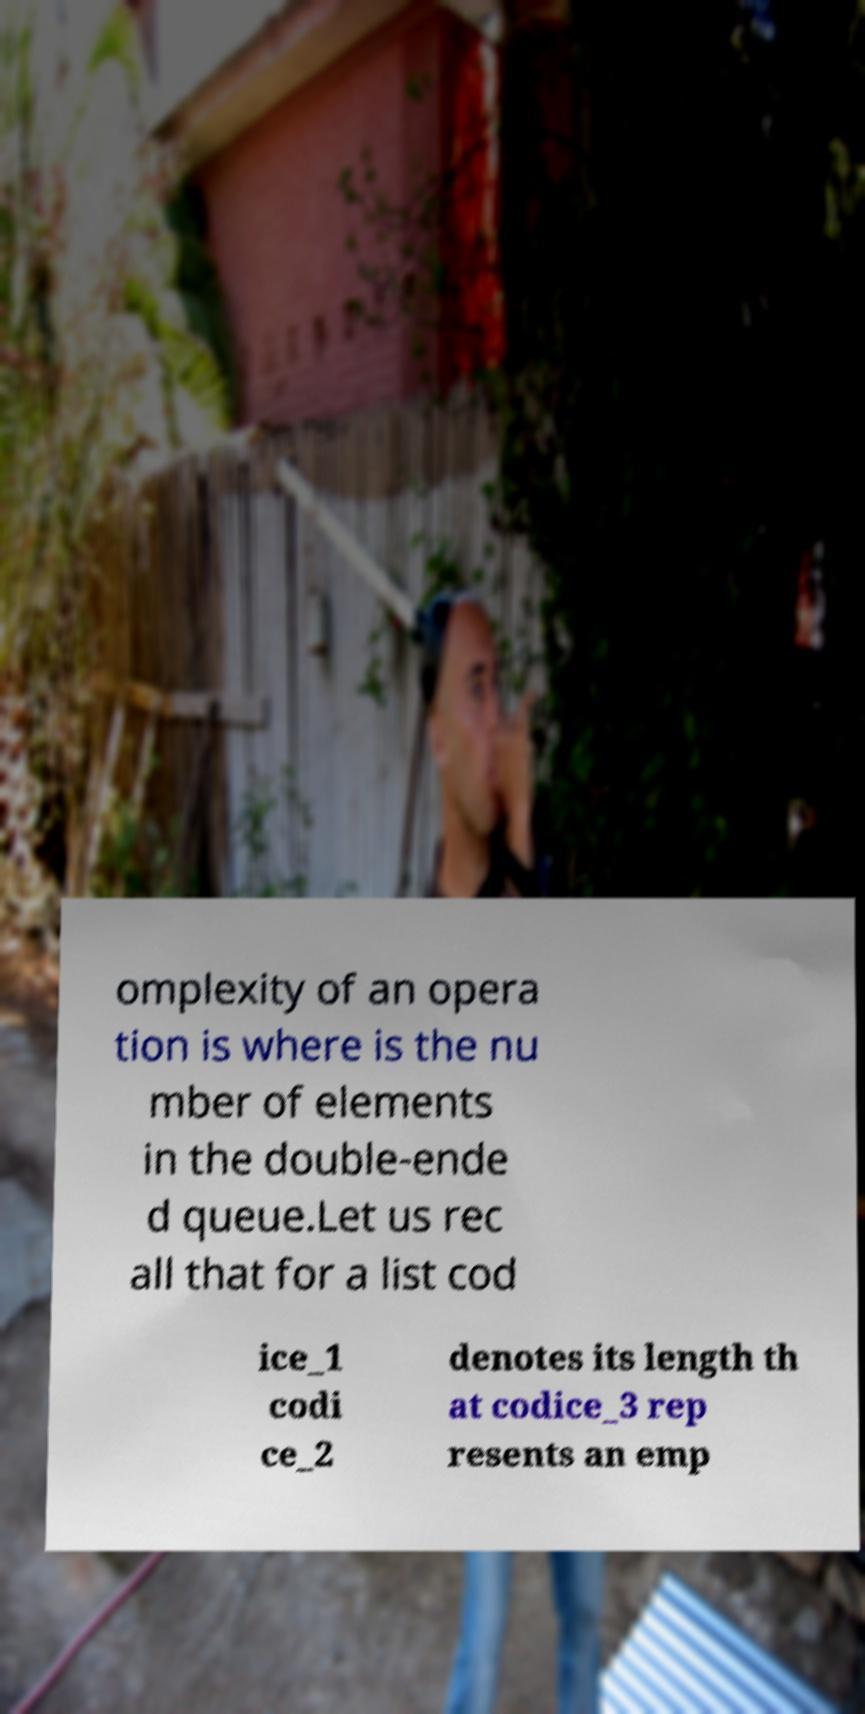There's text embedded in this image that I need extracted. Can you transcribe it verbatim? omplexity of an opera tion is where is the nu mber of elements in the double-ende d queue.Let us rec all that for a list cod ice_1 codi ce_2 denotes its length th at codice_3 rep resents an emp 